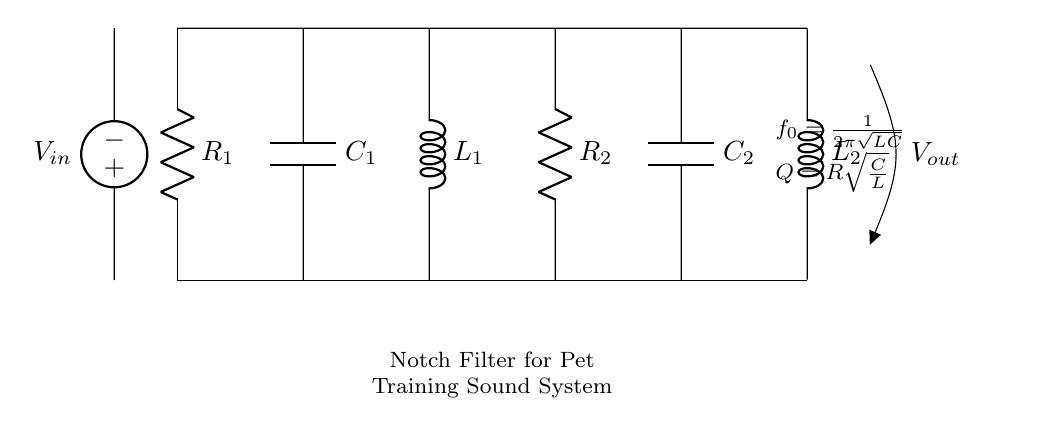What type of filter is represented in the circuit? The circuit represents a notch filter, which is designed to eliminate specific frequencies from a signal. The text in the circuit explicitly indicates this by stating "Notch Filter for Pet Training Sound System."
Answer: Notch filter What components are involved in this notch filter? The circuit includes two resistors (R1 and R2), two capacitors (C1 and C2), and two inductors (L1 and L2). By observing the labeled components in the diagram, we can identify them clearly as part of the circuit structure.
Answer: Resistors, capacitors, inductors What is the formula for the center frequency \( f_0 \)? The formula given in the circuit diagram for calculating the center frequency of the notch filter is \( f_0 = \frac{1}{2\pi\sqrt{LC}} \). This is readily visible in the diagram, indicating how \( f_0 \) is derived.
Answer: \( \frac{1}{2\pi\sqrt{LC}} \) What does \( Q \) represent in the circuit? The symbol \( Q \) in this context refers to the quality factor of the notch filter, which is calculated using the formula \( Q = R\sqrt{\frac{C}{L}} \). This represents how selective the filter is at its center frequency and is derived from the circuit characteristics as shown.
Answer: Quality factor How many energy storage elements are in the circuit? There are four energy storage elements in this circuit: two capacitors (C1 and C2) and two inductors (L1 and L2). This can be determined by counting the labeled components that store energy in an electrical circuit.
Answer: Four Why is a notch filter used in pet training sound systems? A notch filter is used to eliminate unwanted frequencies that may be distracting or ineffective in pet training environments, allowing for clearer communication of sounds that are beneficial for training. This functionality is implicit in the description of the circuit.
Answer: To eliminate unwanted frequencies 